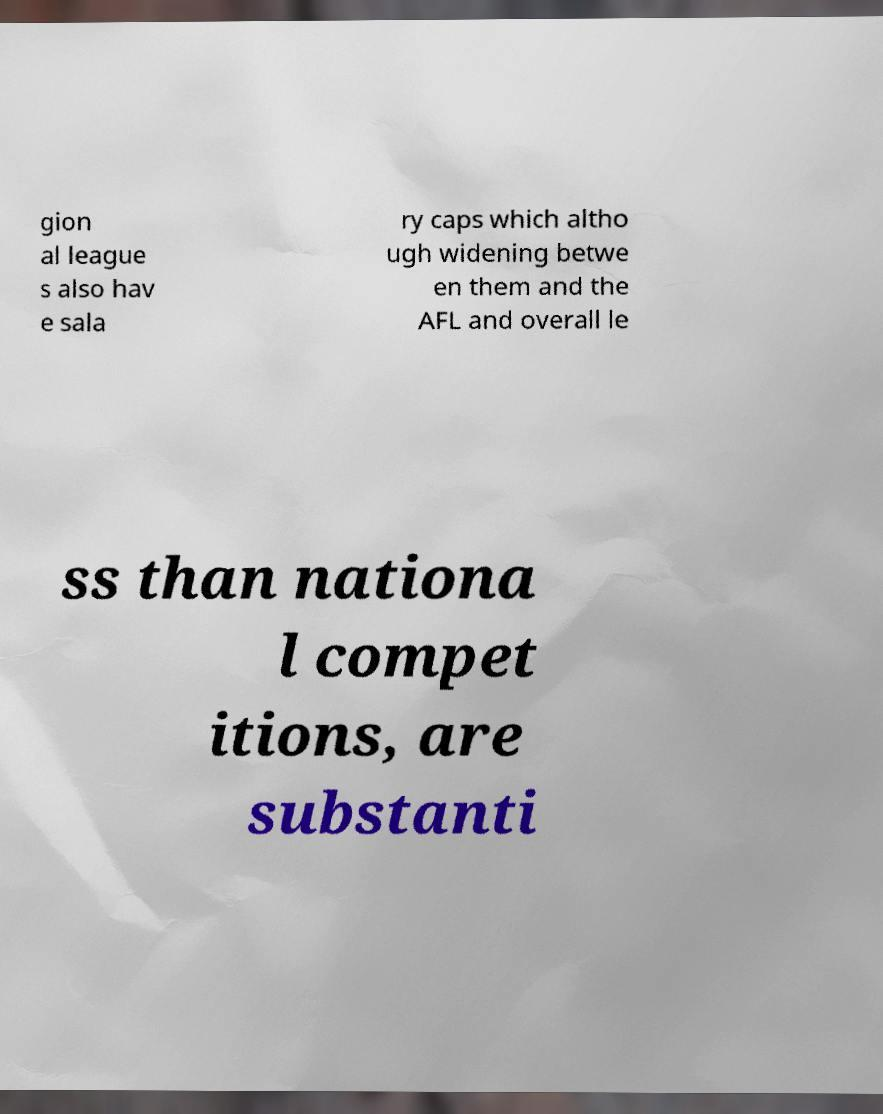Can you read and provide the text displayed in the image?This photo seems to have some interesting text. Can you extract and type it out for me? gion al league s also hav e sala ry caps which altho ugh widening betwe en them and the AFL and overall le ss than nationa l compet itions, are substanti 